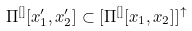Convert formula to latex. <formula><loc_0><loc_0><loc_500><loc_500>\Pi ^ { [ ] } [ x ^ { \prime } _ { 1 } , x ^ { \prime } _ { 2 } ] \subset [ \Pi ^ { [ ] } [ x _ { 1 } , x _ { 2 } ] ] ^ { \uparrow }</formula> 